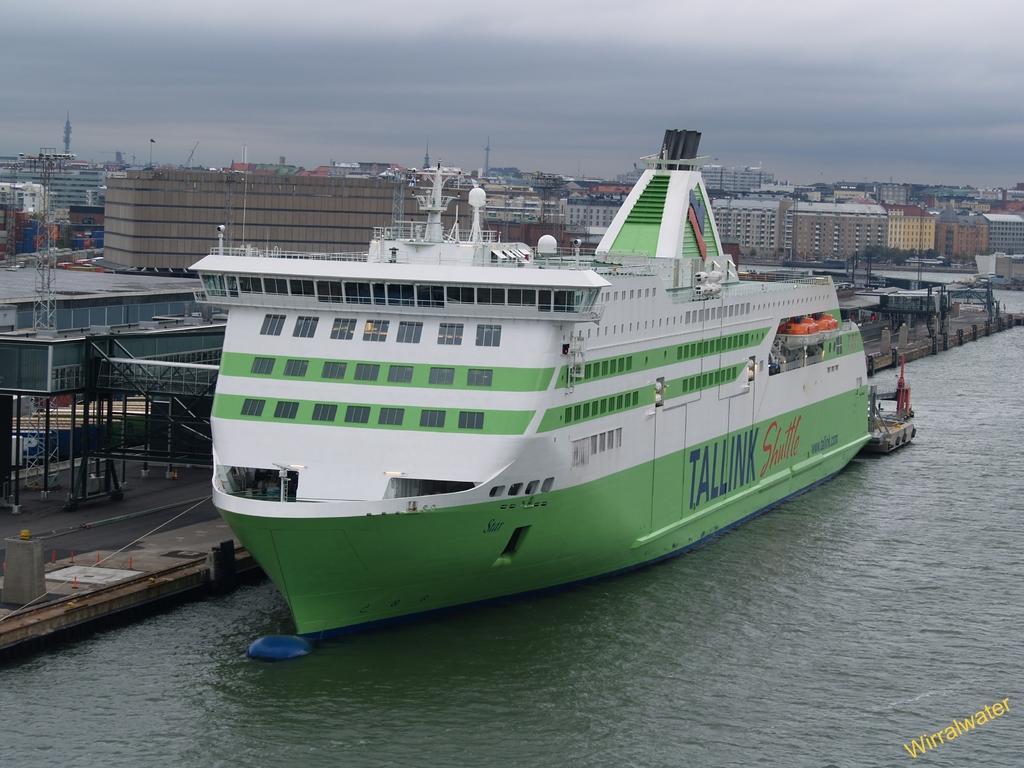Can you describe this image briefly? In this image, we can see a ship and some objects sailing on the water. There are a few buildings and sheds. We can also see some poles and the sky. We can see some text on the bottom right corner. We can also see the ground. 